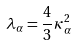<formula> <loc_0><loc_0><loc_500><loc_500>\lambda _ { \alpha } = \frac { 4 } { 3 } \kappa _ { \alpha } ^ { 2 }</formula> 